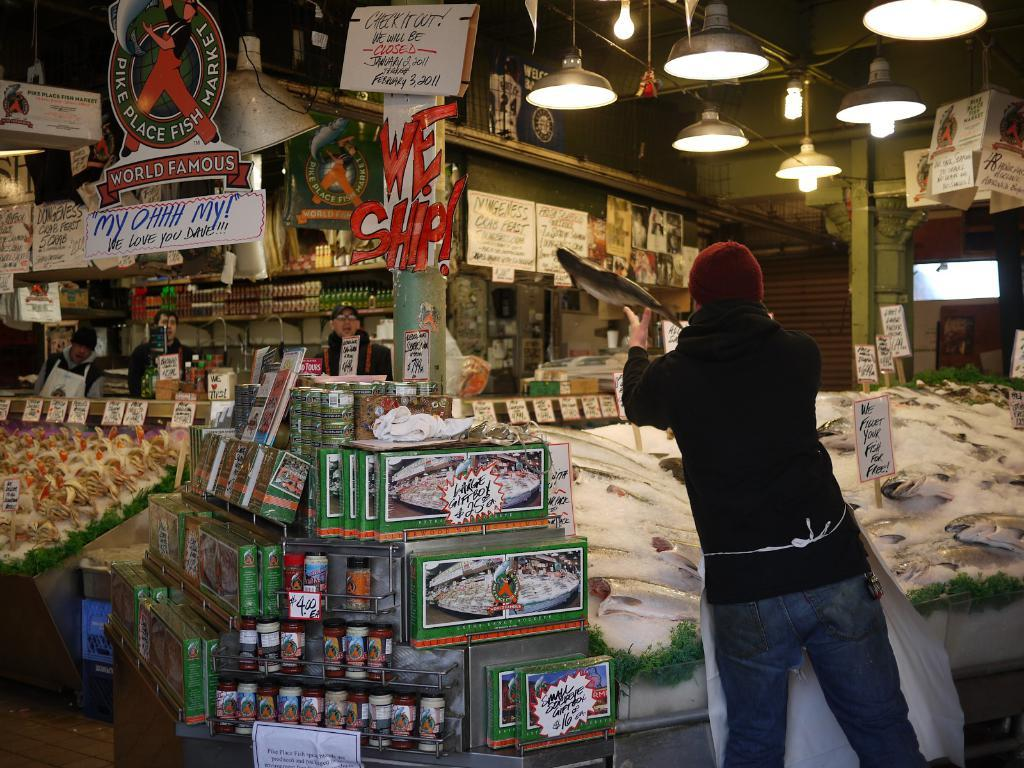Provide a one-sentence caption for the provided image. A man throws a fish near a we ship sign. 